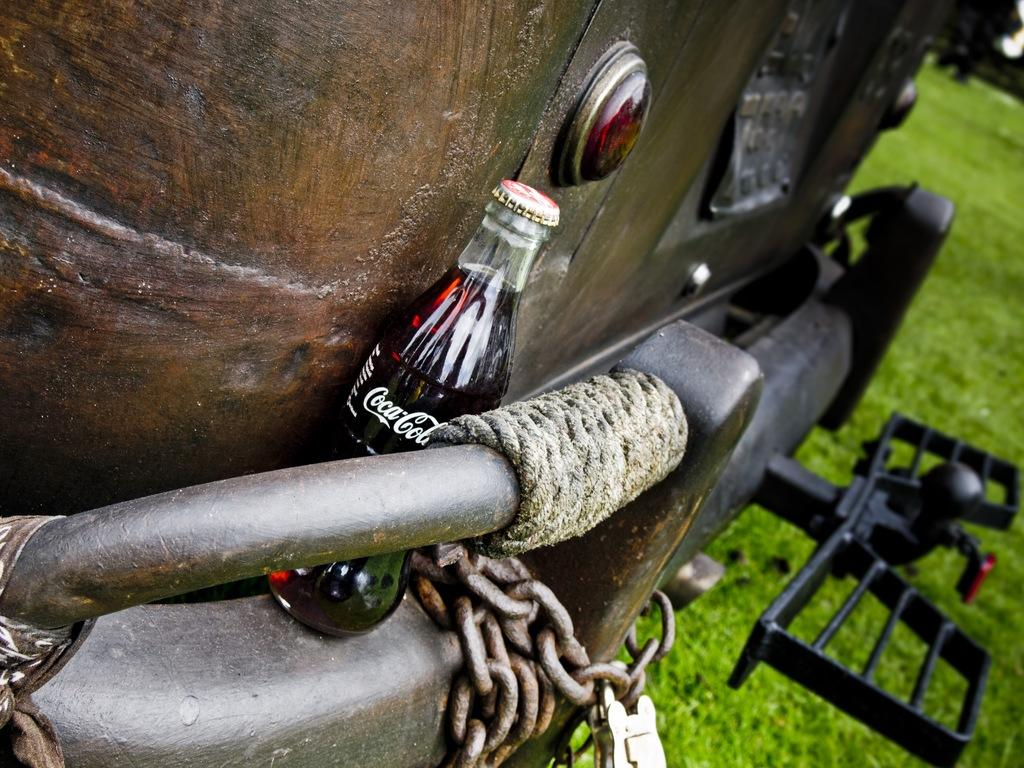What object can be seen in the image that is typically used for holding liquids? There is a bottle in the image. What type of material is present in the image that can be used for tying or securing objects? There is a rope and a chain in the image. What type of vegetation is visible in the image? There is green grass visible in the image. How many toes can be seen on the bear in the image? There are no bears or toes present in the image. What type of attack is being carried out by the bear in the image? There are no bears or attacks present in the image. 